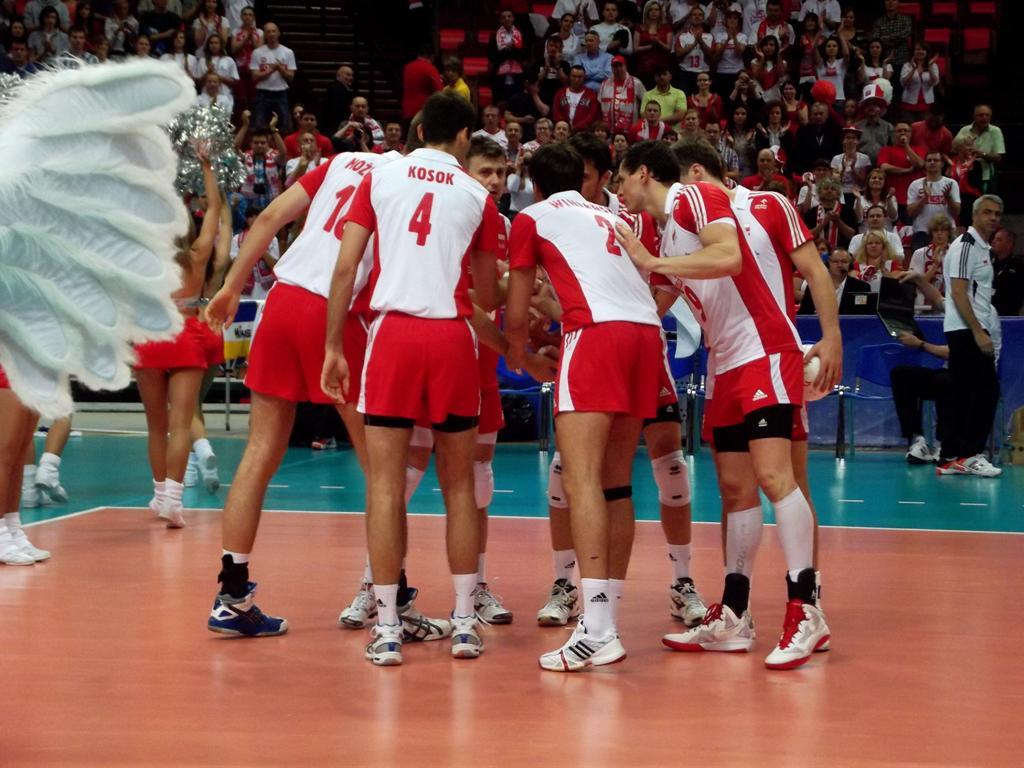What is kosok's number?
Your answer should be compact. 4. 